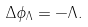<formula> <loc_0><loc_0><loc_500><loc_500>\Delta \phi _ { \Lambda } = - \Lambda .</formula> 